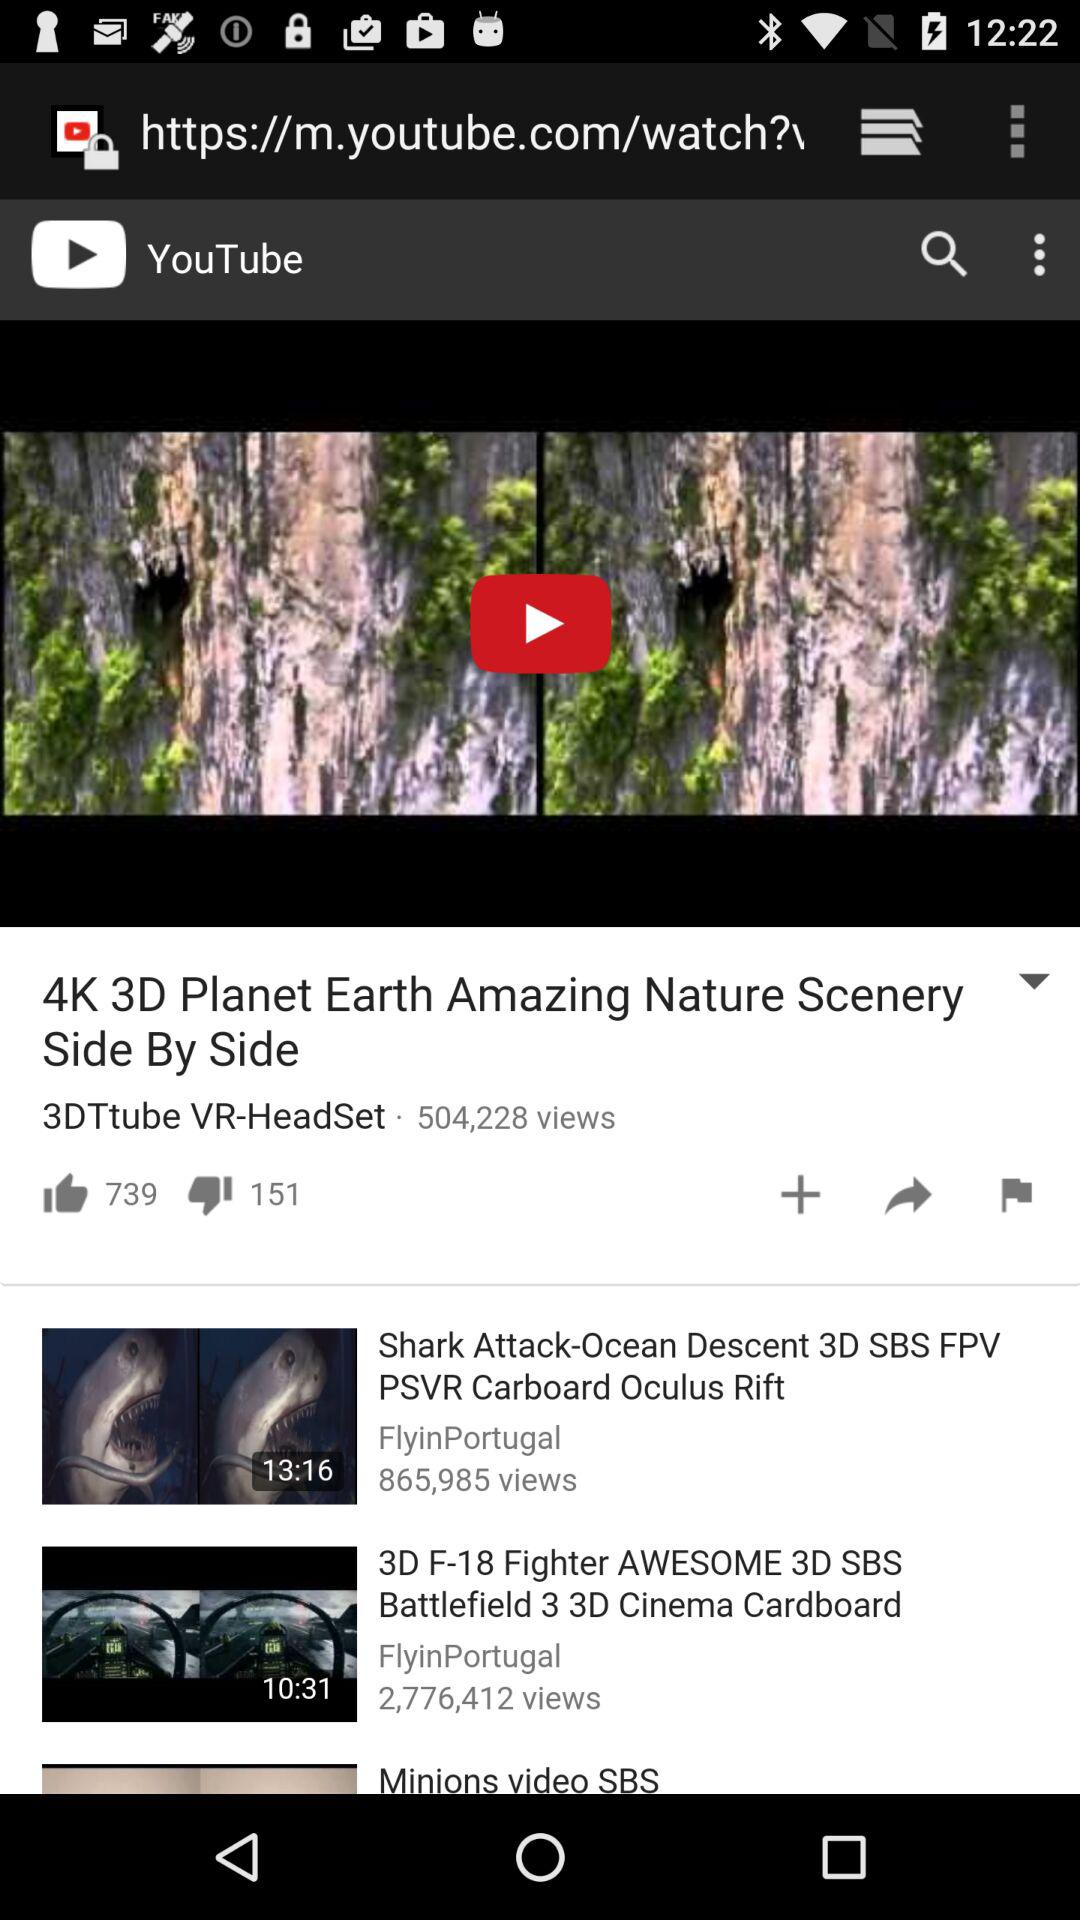How many likes are there on the "4K 3D Planet Earth" video? There are 739 likes. 